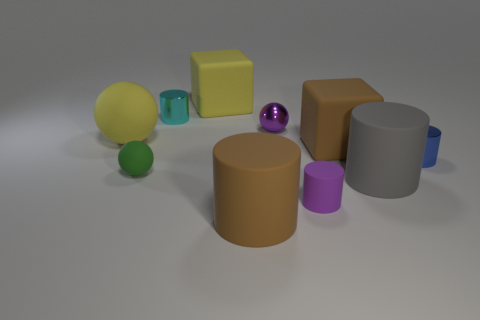How many big yellow rubber spheres are in front of the gray matte thing that is behind the large brown cylinder? 0 